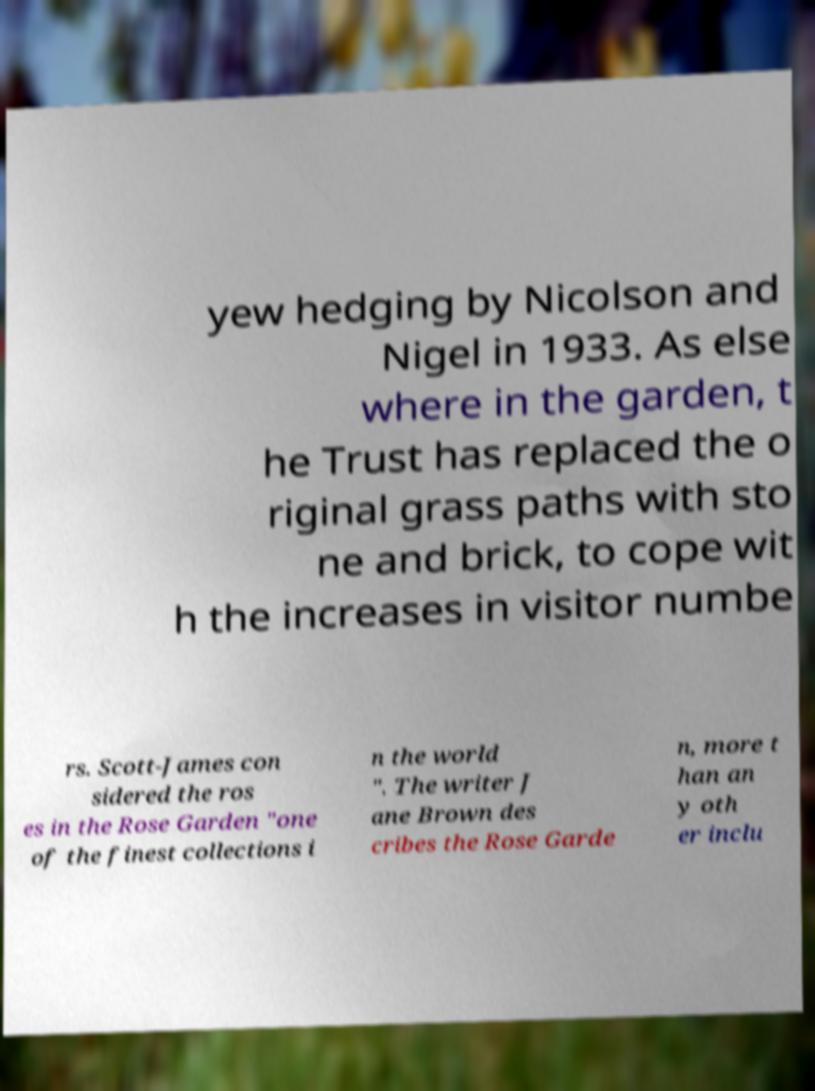Could you assist in decoding the text presented in this image and type it out clearly? yew hedging by Nicolson and Nigel in 1933. As else where in the garden, t he Trust has replaced the o riginal grass paths with sto ne and brick, to cope wit h the increases in visitor numbe rs. Scott-James con sidered the ros es in the Rose Garden "one of the finest collections i n the world ". The writer J ane Brown des cribes the Rose Garde n, more t han an y oth er inclu 